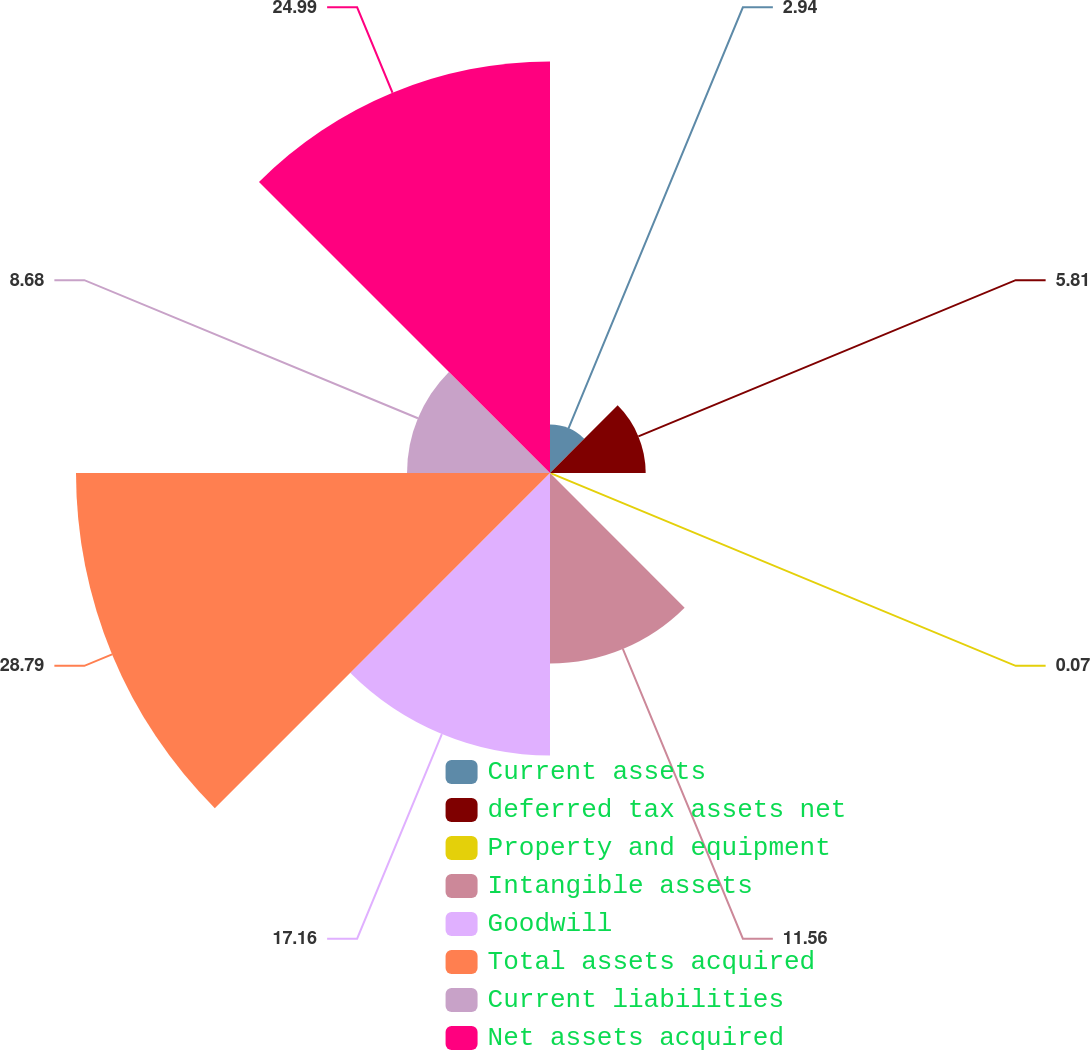<chart> <loc_0><loc_0><loc_500><loc_500><pie_chart><fcel>Current assets<fcel>deferred tax assets net<fcel>Property and equipment<fcel>Intangible assets<fcel>Goodwill<fcel>Total assets acquired<fcel>Current liabilities<fcel>Net assets acquired<nl><fcel>2.94%<fcel>5.81%<fcel>0.07%<fcel>11.56%<fcel>17.16%<fcel>28.78%<fcel>8.68%<fcel>24.99%<nl></chart> 